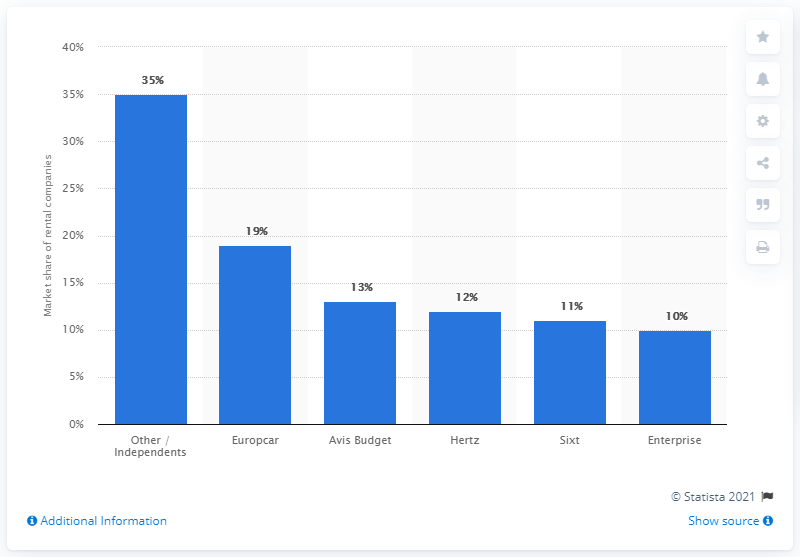Outline some significant characteristics in this image. In 2015, Europcar was the leading car rental company in the European Union. The second largest car rental company in the European Union in 2015 was Sixt. 